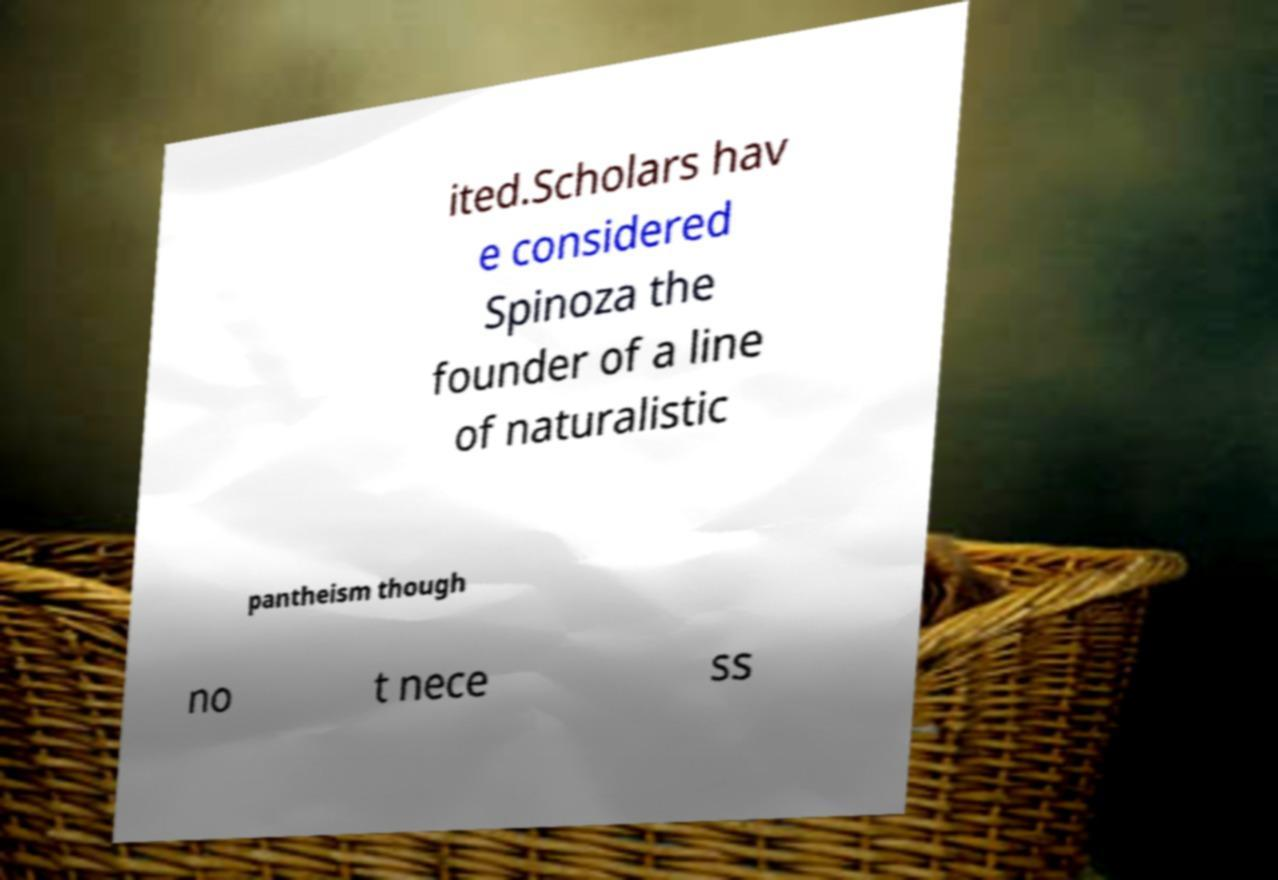There's text embedded in this image that I need extracted. Can you transcribe it verbatim? ited.Scholars hav e considered Spinoza the founder of a line of naturalistic pantheism though no t nece ss 